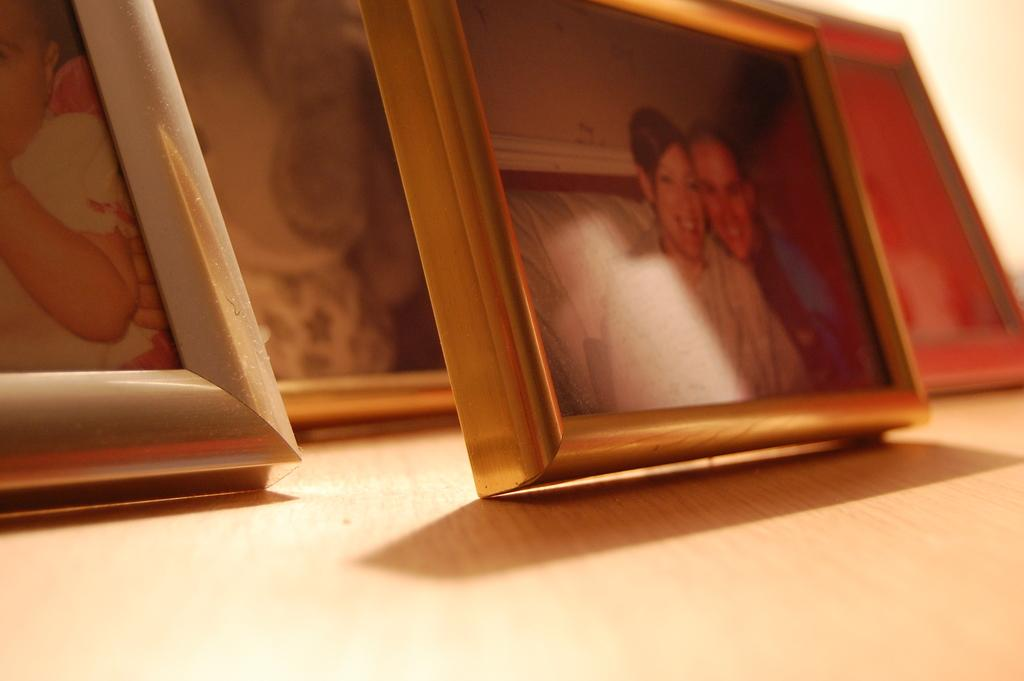What objects are present in the image? There are photo frames in the image. Can you describe the photo frames in more detail? Unfortunately, the provided facts do not offer any additional details about the photo frames. Are there any other objects or people visible in the image? The given facts only mention the presence of photo frames, so we cannot determine if there are any other objects or people in the image. What month is depicted in the photo frames? The provided facts do not mention any specific photos or images within the photo frames, so we cannot determine the month depicted in them. 